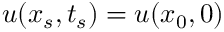<formula> <loc_0><loc_0><loc_500><loc_500>u ( x _ { s } , t _ { s } ) = u ( x _ { 0 } , 0 )</formula> 